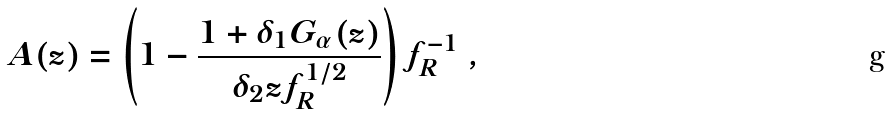Convert formula to latex. <formula><loc_0><loc_0><loc_500><loc_500>A ( z ) = \left ( 1 - \frac { 1 + \delta _ { 1 } G _ { \alpha } ( z ) } { \delta _ { 2 } z f _ { R } ^ { 1 / 2 } } \right ) f ^ { - 1 } _ { R } \ ,</formula> 